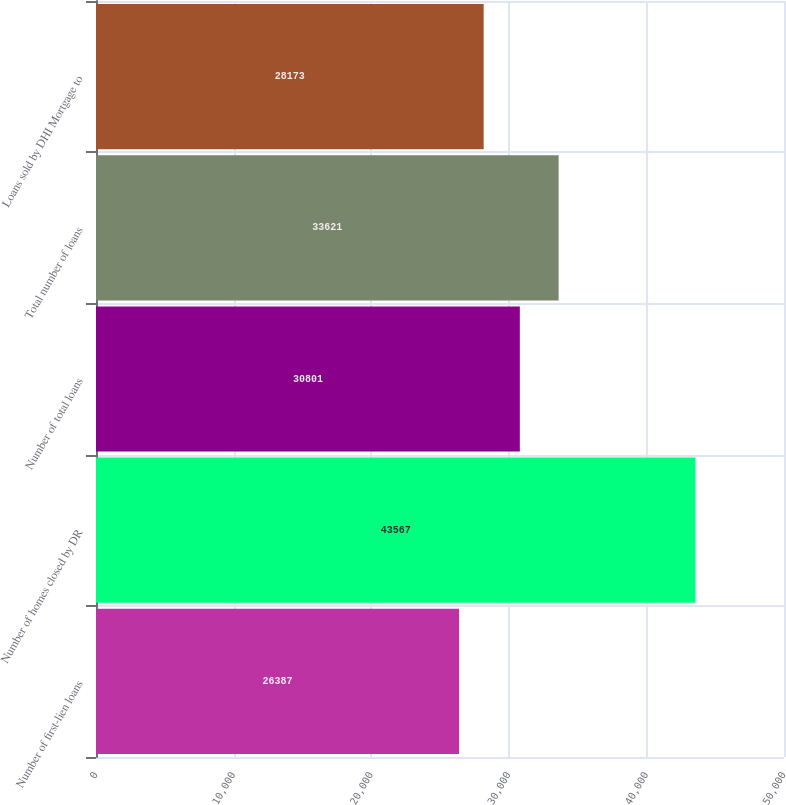Convert chart. <chart><loc_0><loc_0><loc_500><loc_500><bar_chart><fcel>Number of first-lien loans<fcel>Number of homes closed by DR<fcel>Number of total loans<fcel>Total number of loans<fcel>Loans sold by DHI Mortgage to<nl><fcel>26387<fcel>43567<fcel>30801<fcel>33621<fcel>28173<nl></chart> 